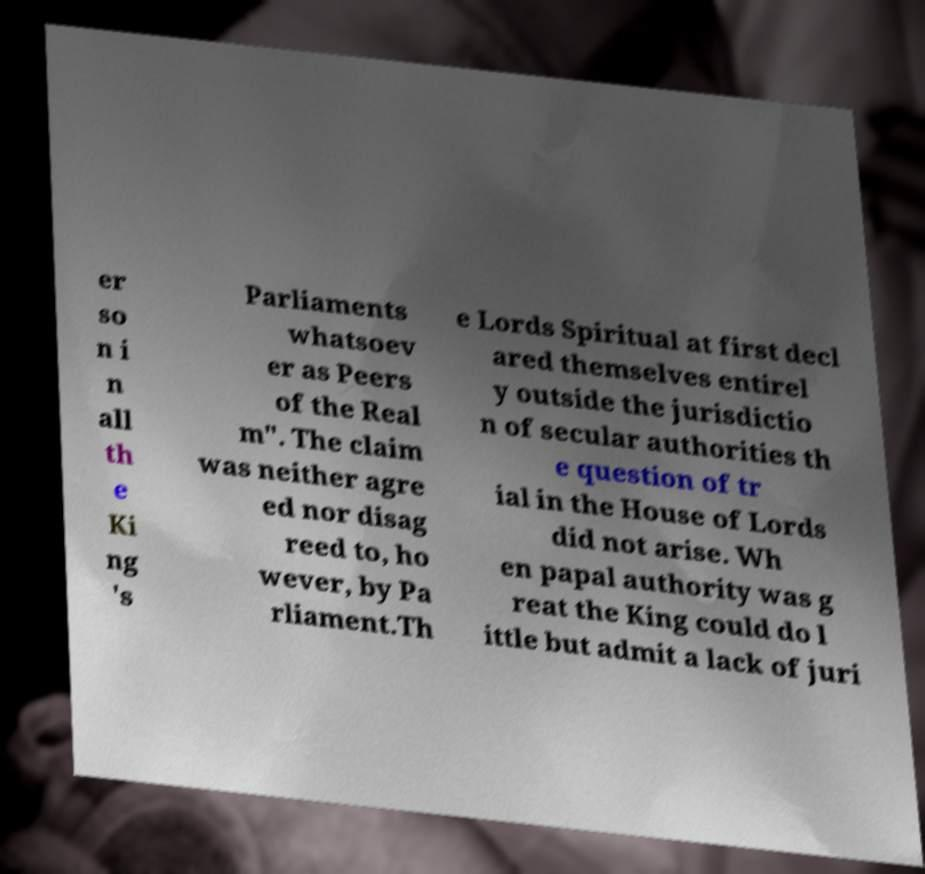I need the written content from this picture converted into text. Can you do that? er so n i n all th e Ki ng 's Parliaments whatsoev er as Peers of the Real m". The claim was neither agre ed nor disag reed to, ho wever, by Pa rliament.Th e Lords Spiritual at first decl ared themselves entirel y outside the jurisdictio n of secular authorities th e question of tr ial in the House of Lords did not arise. Wh en papal authority was g reat the King could do l ittle but admit a lack of juri 